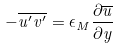<formula> <loc_0><loc_0><loc_500><loc_500>- \overline { u ^ { \prime } v ^ { \prime } } = \epsilon _ { M } \frac { \partial \overline { u } } { \partial y }</formula> 